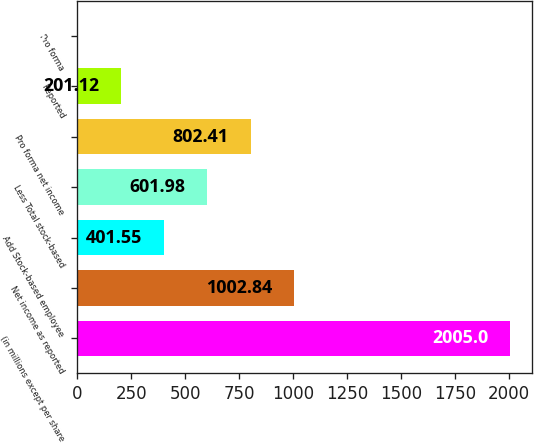Convert chart. <chart><loc_0><loc_0><loc_500><loc_500><bar_chart><fcel>(in millions except per share<fcel>Net income as reported<fcel>Add Stock-based employee<fcel>Less Total stock-based<fcel>Pro forma net income<fcel>Reported<fcel>Pro forma<nl><fcel>2005<fcel>1002.84<fcel>401.55<fcel>601.98<fcel>802.41<fcel>201.12<fcel>0.69<nl></chart> 